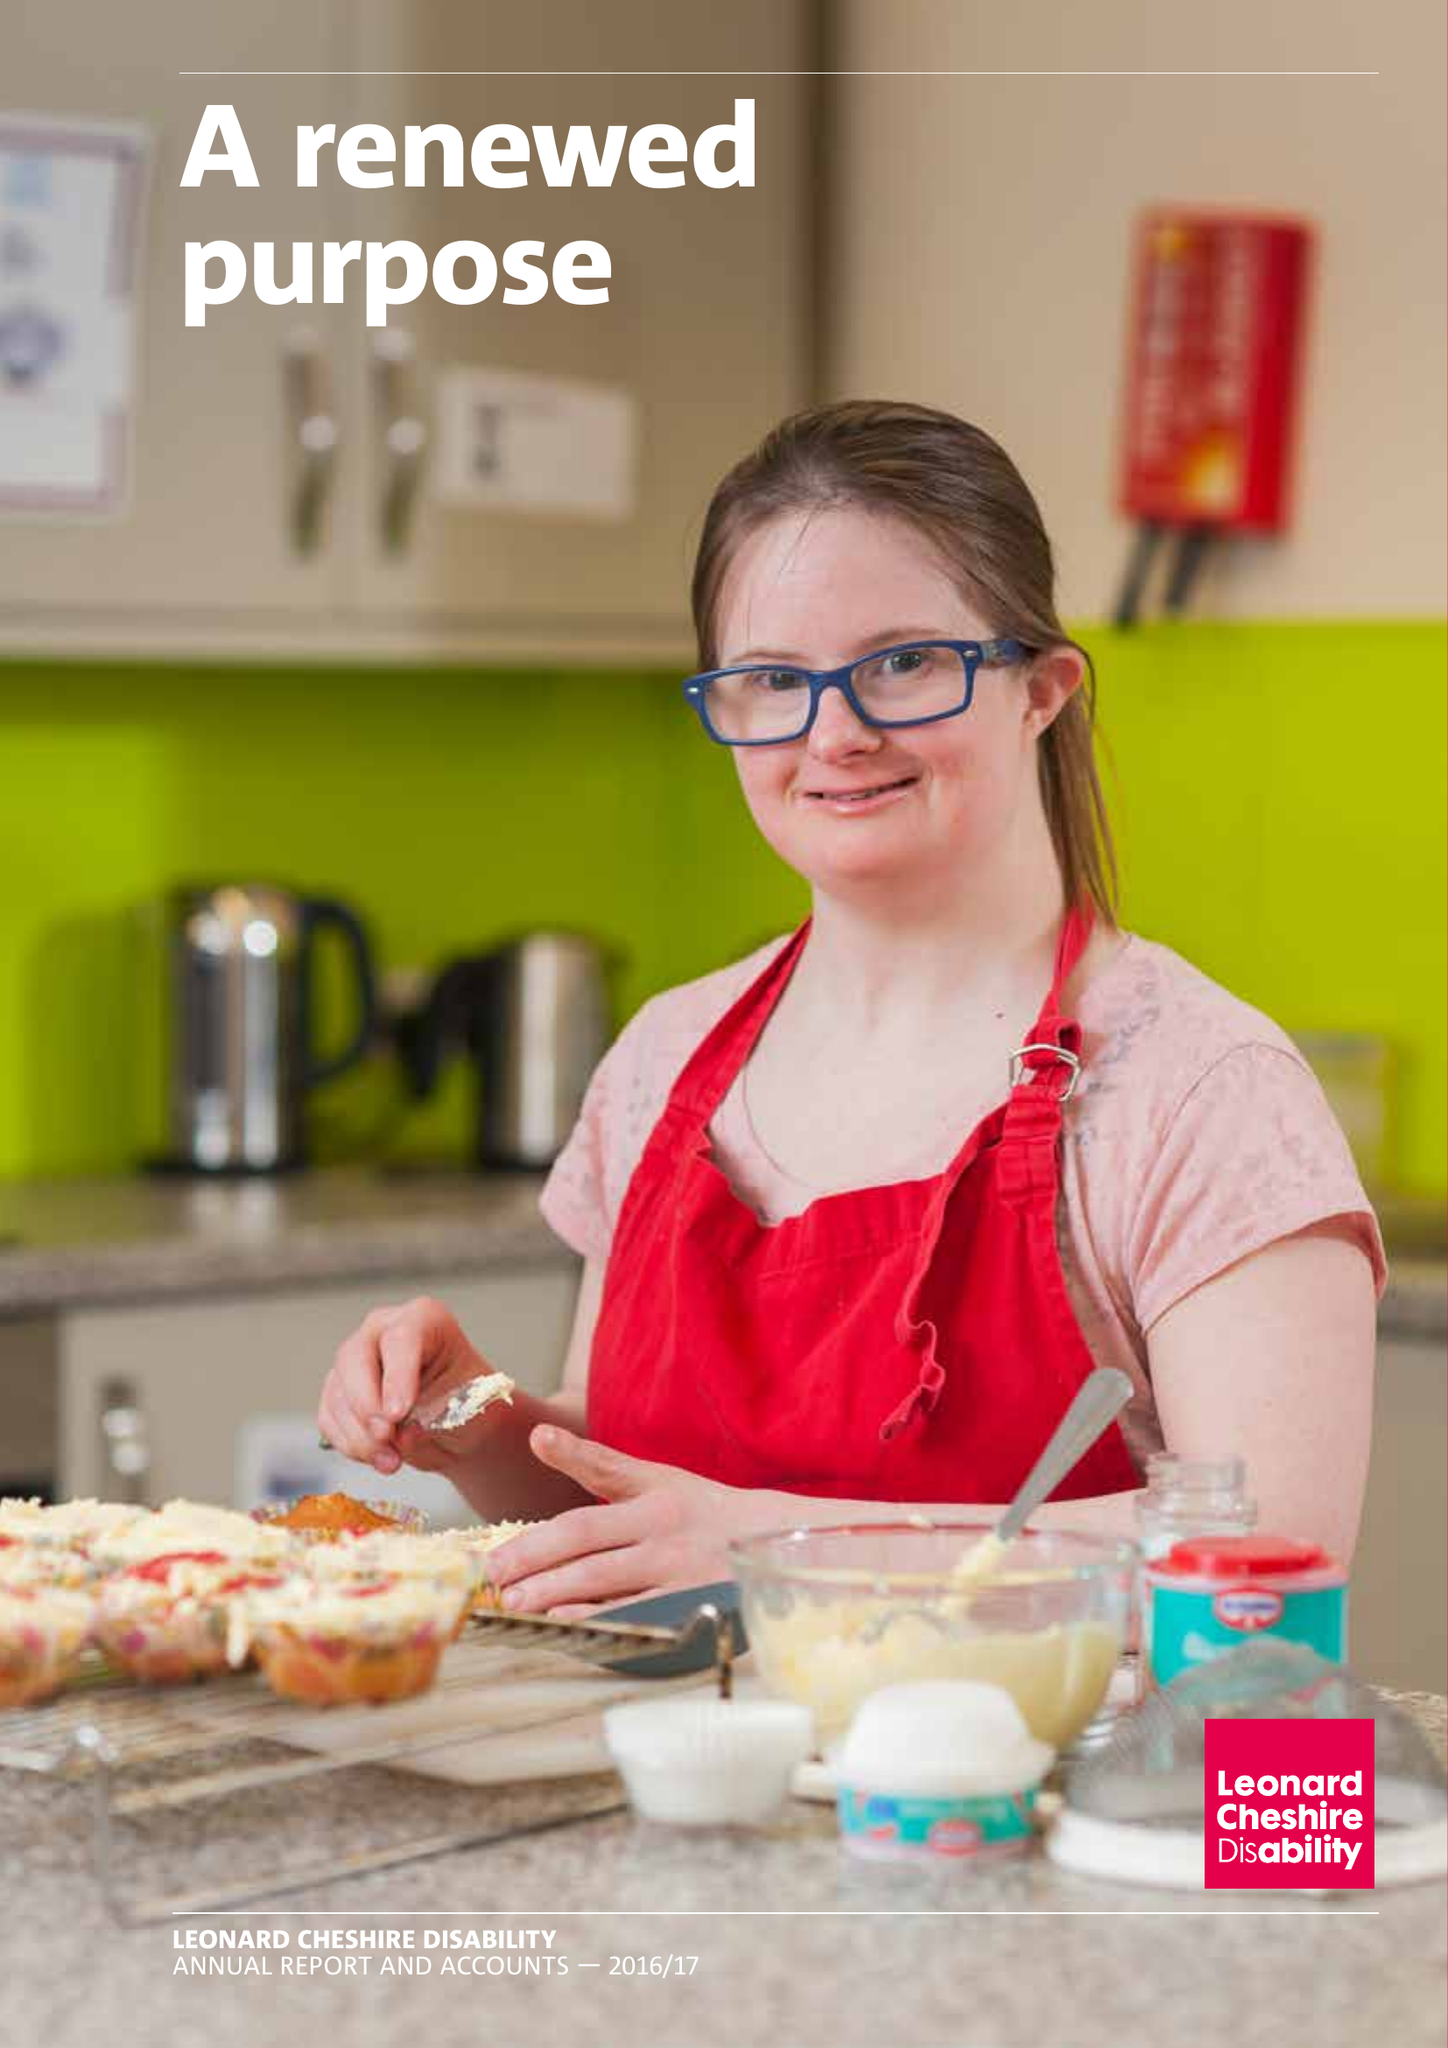What is the value for the report_date?
Answer the question using a single word or phrase. 2017-03-31 